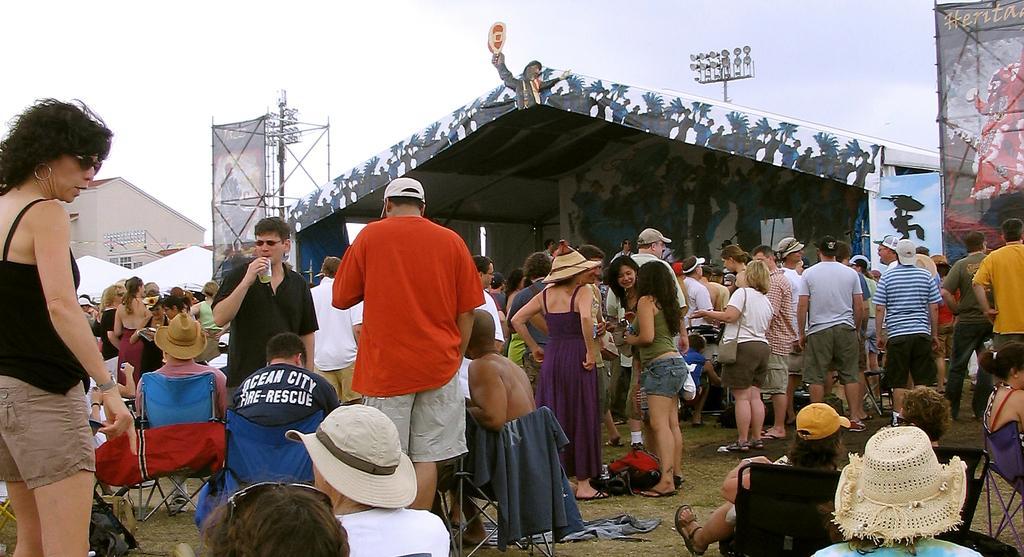How would you summarize this image in a sentence or two? In the foreground of this image, there are people standing and sitting on the chairs. In the background, there is a shed, two banners to the poles, two light poles and a building. At the top, there is the sky. 